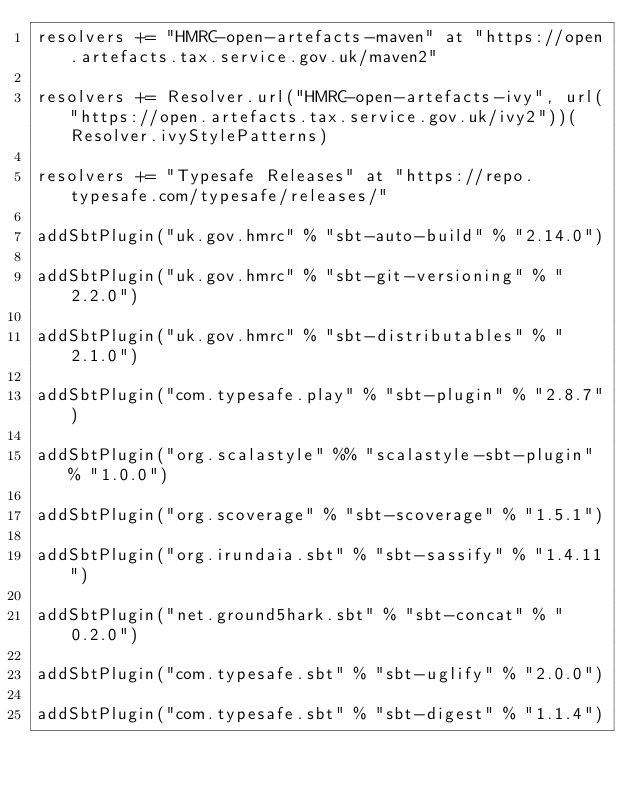Convert code to text. <code><loc_0><loc_0><loc_500><loc_500><_Scala_>resolvers += "HMRC-open-artefacts-maven" at "https://open.artefacts.tax.service.gov.uk/maven2"

resolvers += Resolver.url("HMRC-open-artefacts-ivy", url("https://open.artefacts.tax.service.gov.uk/ivy2"))(Resolver.ivyStylePatterns)

resolvers += "Typesafe Releases" at "https://repo.typesafe.com/typesafe/releases/"

addSbtPlugin("uk.gov.hmrc" % "sbt-auto-build" % "2.14.0")

addSbtPlugin("uk.gov.hmrc" % "sbt-git-versioning" % "2.2.0")

addSbtPlugin("uk.gov.hmrc" % "sbt-distributables" % "2.1.0")

addSbtPlugin("com.typesafe.play" % "sbt-plugin" % "2.8.7")

addSbtPlugin("org.scalastyle" %% "scalastyle-sbt-plugin" % "1.0.0")

addSbtPlugin("org.scoverage" % "sbt-scoverage" % "1.5.1")

addSbtPlugin("org.irundaia.sbt" % "sbt-sassify" % "1.4.11")

addSbtPlugin("net.ground5hark.sbt" % "sbt-concat" % "0.2.0")

addSbtPlugin("com.typesafe.sbt" % "sbt-uglify" % "2.0.0")

addSbtPlugin("com.typesafe.sbt" % "sbt-digest" % "1.1.4")
</code> 